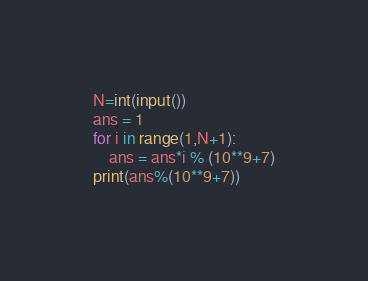<code> <loc_0><loc_0><loc_500><loc_500><_Python_>N=int(input())
ans = 1
for i in range(1,N+1):
    ans = ans*i % (10**9+7)
print(ans%(10**9+7))</code> 